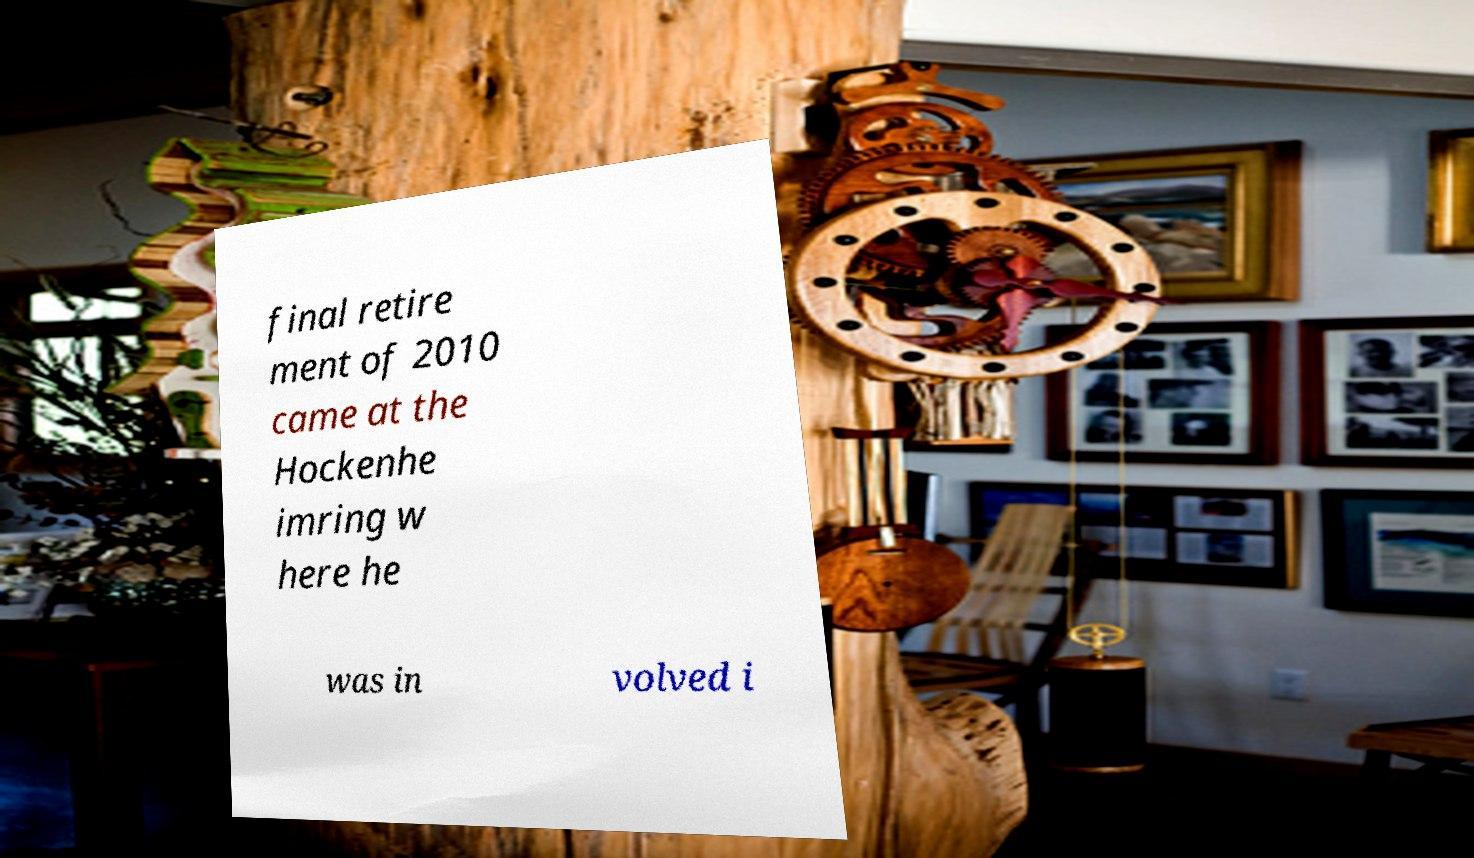Can you read and provide the text displayed in the image?This photo seems to have some interesting text. Can you extract and type it out for me? final retire ment of 2010 came at the Hockenhe imring w here he was in volved i 